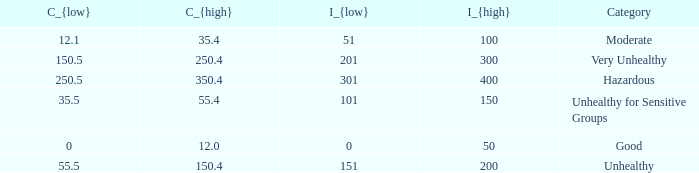How many different C_{high} values are there for the good category? 1.0. 